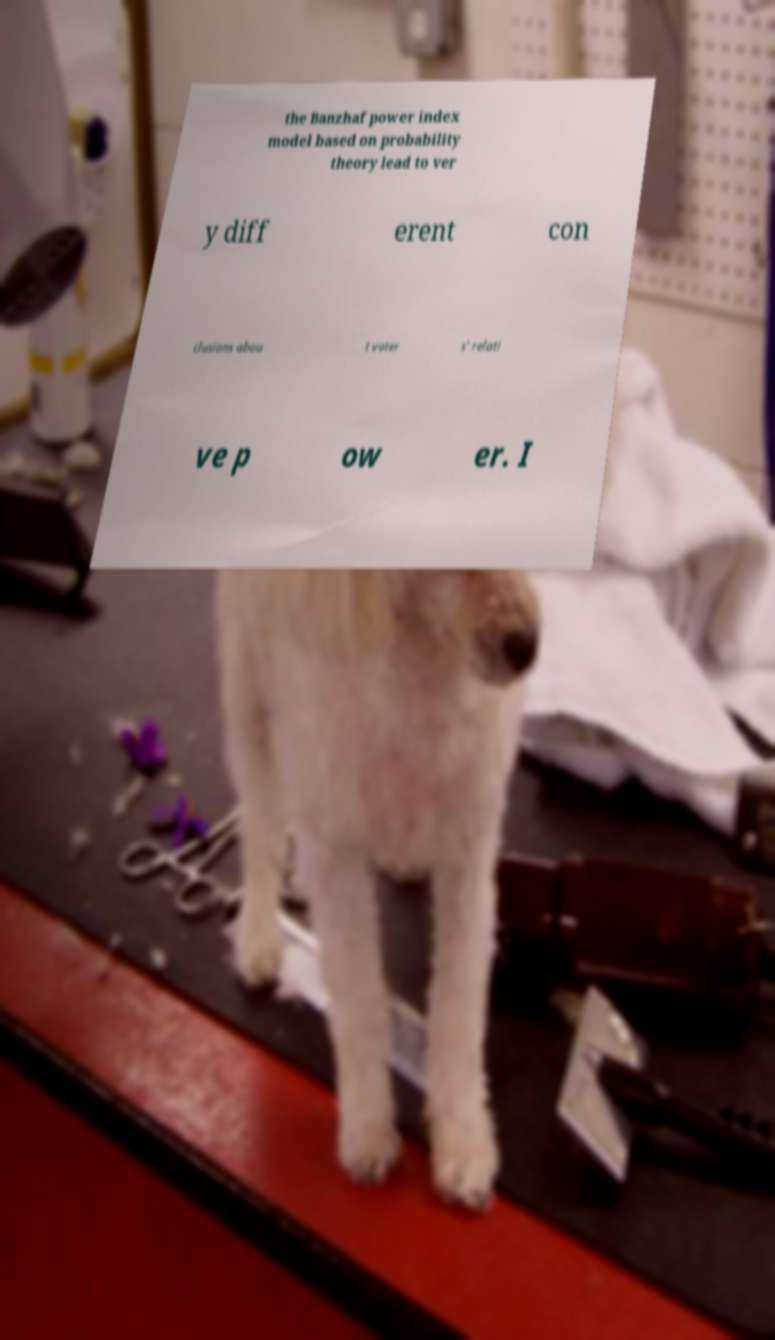There's text embedded in this image that I need extracted. Can you transcribe it verbatim? the Banzhaf power index model based on probability theory lead to ver y diff erent con clusions abou t voter s' relati ve p ow er. I 